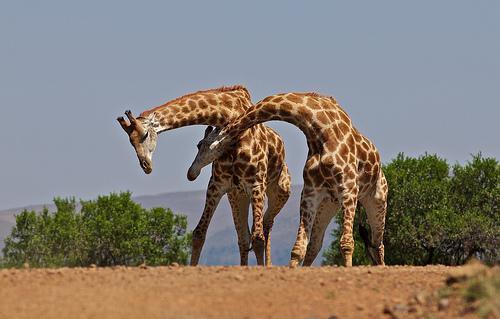How many giraffe on the ground?
Give a very brief answer. 2. 